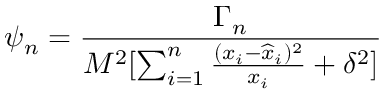Convert formula to latex. <formula><loc_0><loc_0><loc_500><loc_500>\psi _ { n } = { \frac { \Gamma _ { n } } { M ^ { 2 } [ \sum _ { i = 1 } ^ { n } { \frac { ( x _ { i } - { \widehat { x } } _ { i } ) ^ { 2 } } { x _ { i } } } + \delta ^ { 2 } ] } }</formula> 